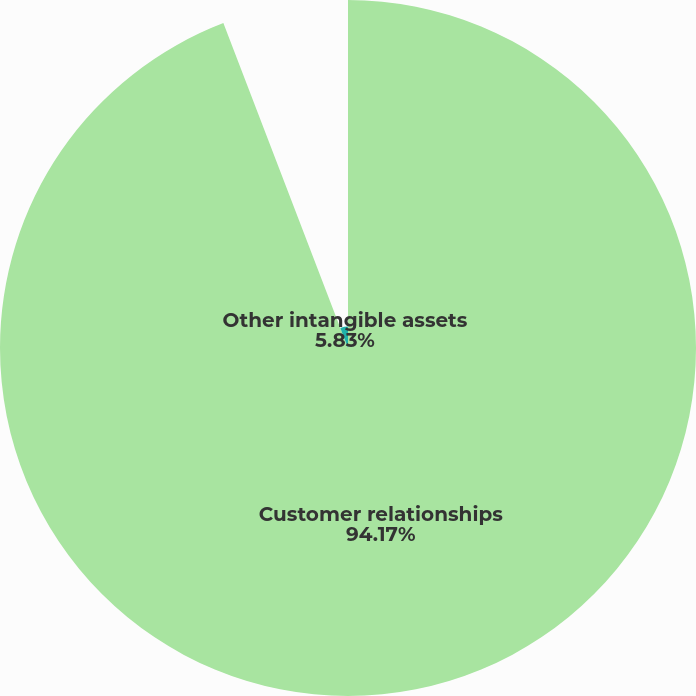<chart> <loc_0><loc_0><loc_500><loc_500><pie_chart><fcel>Customer relationships<fcel>Other intangible assets<nl><fcel>94.17%<fcel>5.83%<nl></chart> 